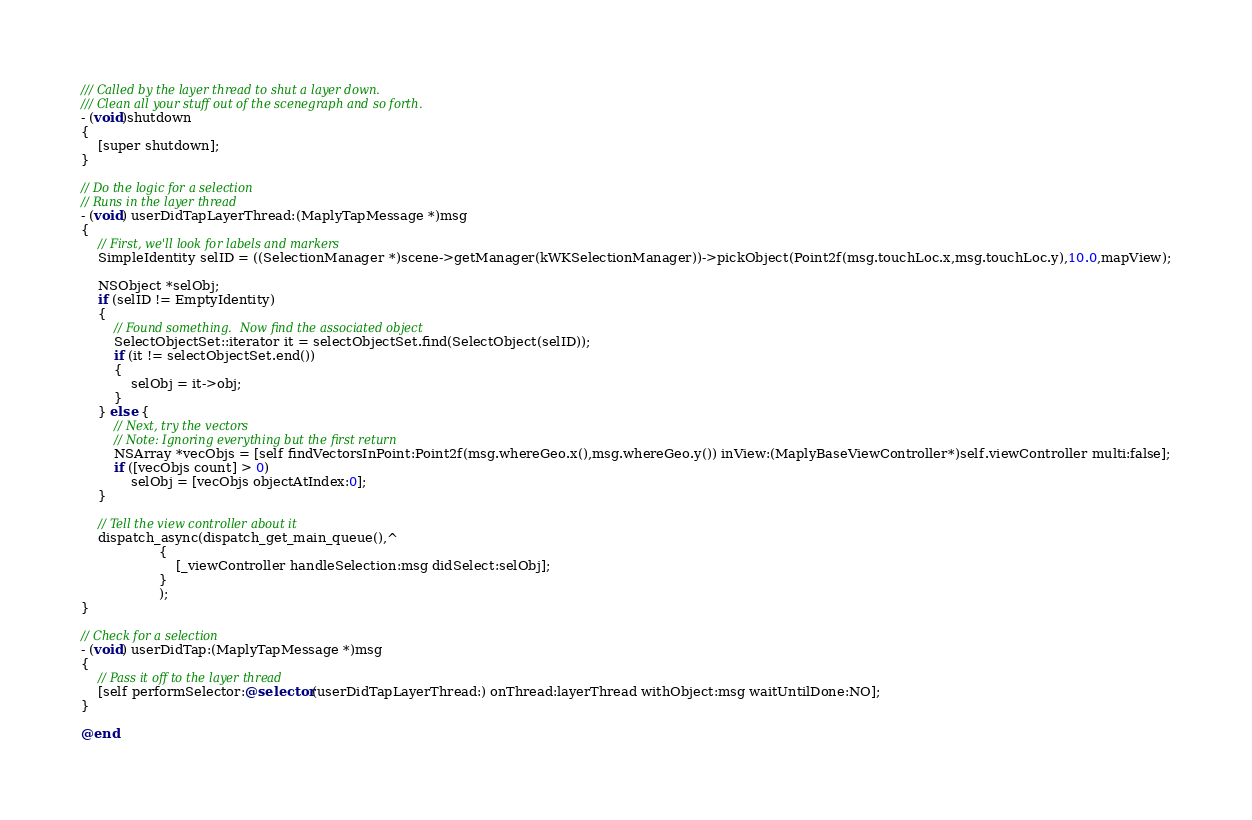<code> <loc_0><loc_0><loc_500><loc_500><_ObjectiveC_>
/// Called by the layer thread to shut a layer down.
/// Clean all your stuff out of the scenegraph and so forth.
- (void)shutdown
{
    [super shutdown];
}

// Do the logic for a selection
// Runs in the layer thread
- (void) userDidTapLayerThread:(MaplyTapMessage *)msg
{
    // First, we'll look for labels and markers
    SimpleIdentity selID = ((SelectionManager *)scene->getManager(kWKSelectionManager))->pickObject(Point2f(msg.touchLoc.x,msg.touchLoc.y),10.0,mapView);

    NSObject *selObj;
    if (selID != EmptyIdentity)
    {       
        // Found something.  Now find the associated object
        SelectObjectSet::iterator it = selectObjectSet.find(SelectObject(selID));
        if (it != selectObjectSet.end())
        {
            selObj = it->obj;
        }
    } else {
        // Next, try the vectors
        // Note: Ignoring everything but the first return
        NSArray *vecObjs = [self findVectorsInPoint:Point2f(msg.whereGeo.x(),msg.whereGeo.y()) inView:(MaplyBaseViewController*)self.viewController multi:false];
        if ([vecObjs count] > 0)
            selObj = [vecObjs objectAtIndex:0];
    }
    
    // Tell the view controller about it
    dispatch_async(dispatch_get_main_queue(),^
                   {
                       [_viewController handleSelection:msg didSelect:selObj];
                   }
                   );
}

// Check for a selection
- (void) userDidTap:(MaplyTapMessage *)msg
{
    // Pass it off to the layer thread
    [self performSelector:@selector(userDidTapLayerThread:) onThread:layerThread withObject:msg waitUntilDone:NO];
}

@end</code> 